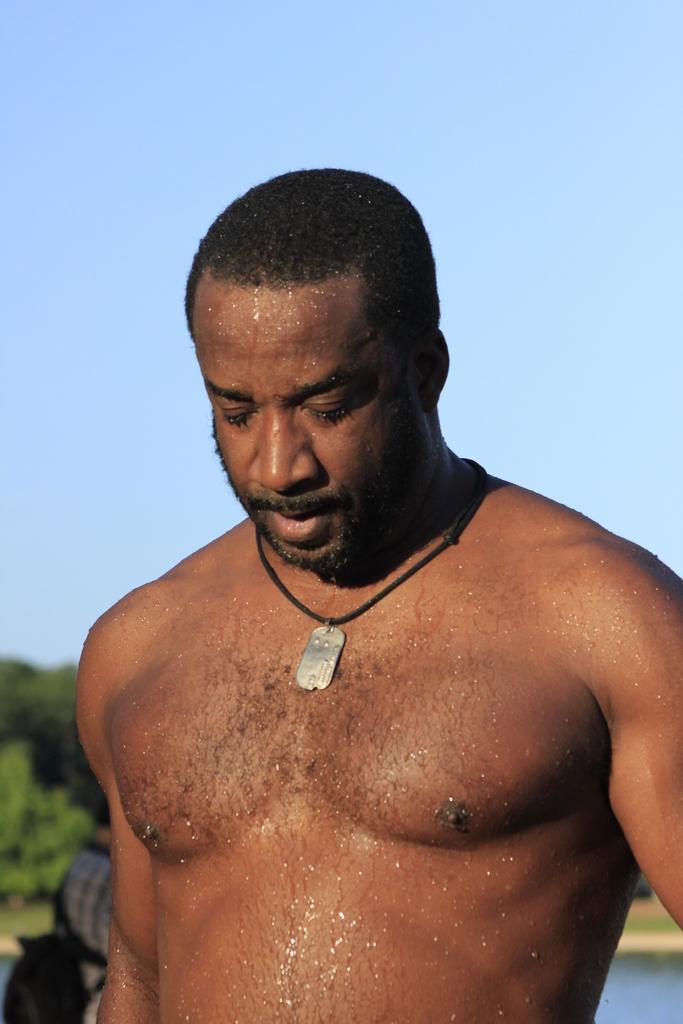How would you summarize this image in a sentence or two? In this image I can see the person. To the left I can see another person with the dress and the bag. In the background I can see the trees, water and the sky. 